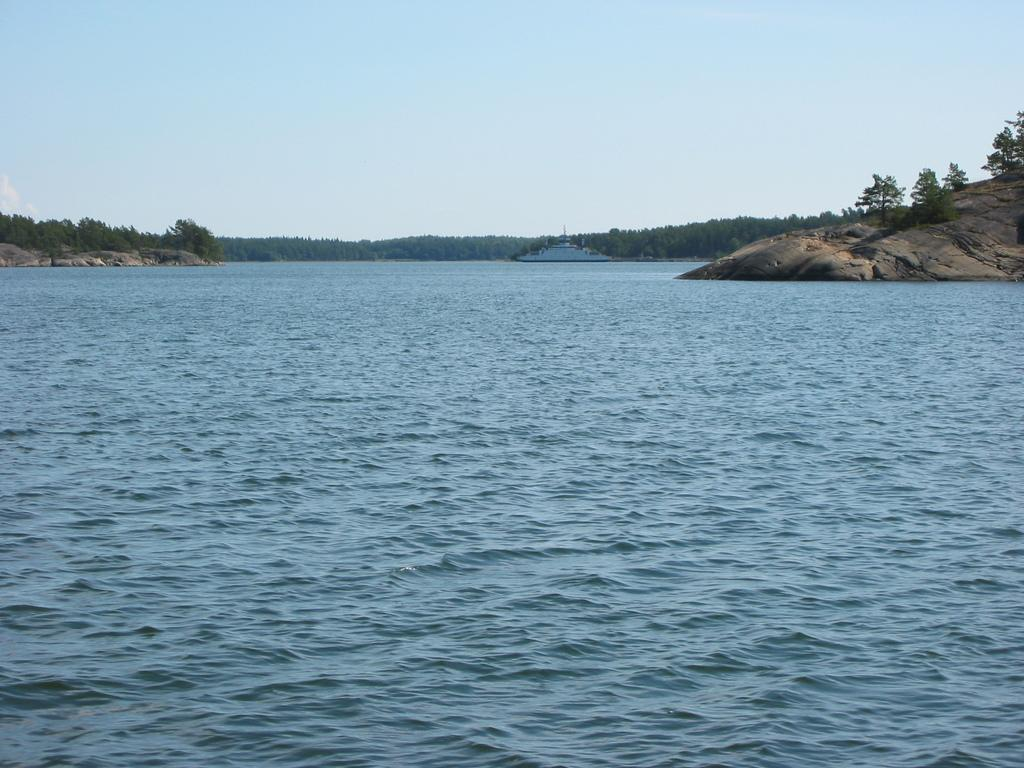What type of natural elements can be seen in the image? There are trees and rocks in the image. What is located on the water in the image? There is a boat on the water in the image. What is visible at the top of the image? The sky is visible at the top of the image. What type of polish is being applied to the horse in the image? There is no horse or polish present in the image. Can you see any smoke coming from the boat in the image? There is no smoke visible in the image; the boat is on the water. 